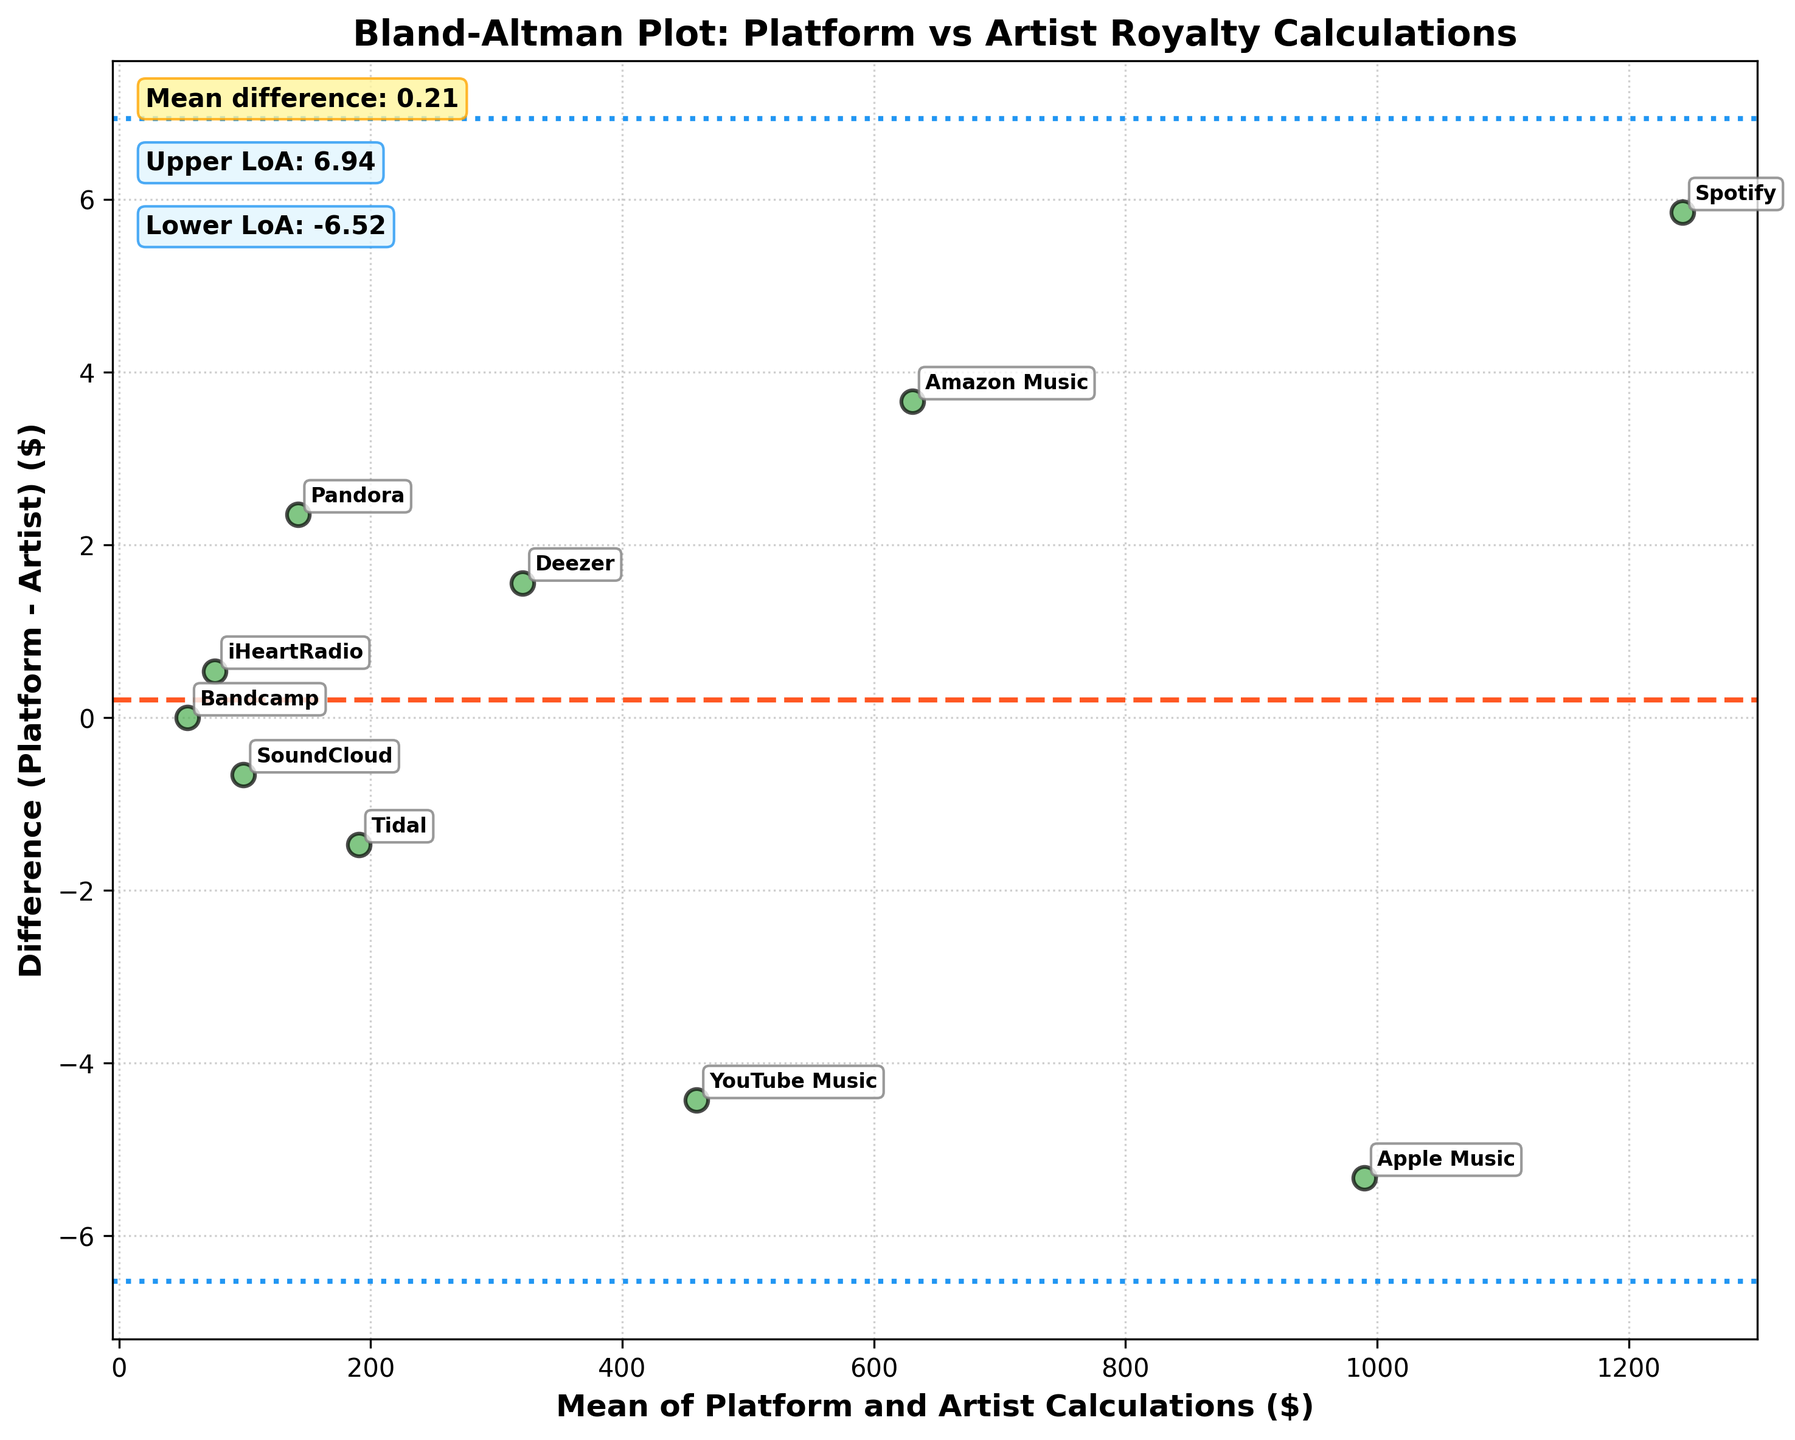How many data points are plotted on the Bland-Altman plot? There are labels for each streaming platform (e.g., Spotify, Apple Music), so counting these labels will give the total number of data points. By counting, there are labels for Spotify, Apple Music, Amazon Music, YouTube Music, Deezer, Tidal, Pandora, SoundCloud, iHeartRadio, and Bandcamp.
Answer: 10 What is the mean difference between the platform and artist royalty calculations? The mean difference is denoted by the dashed orange line. It is also provided in the textbox on the upper left corner of the plot. The value given there is the mean difference.
Answer: -1.12 What are the upper and lower limits of agreement? The upper and lower limits of agreement are shown by the blue dashed lines. Their exact values are given in text boxes in the upper left corner of the plot. According to the figure, the upper limit is 4.28 and the lower limit is -6.52.
Answer: 4.28, -6.52 Which streaming platform has the largest positive difference between platform and artist calculations? By examining the vertical distances above the 0 line, the largest positive difference is for YouTube Music since its marker is the highest above the 0 mark.
Answer: YouTube Music Which streaming platform has the largest negative difference between platform and artist calculations? By examining the vertical distances below the 0 line, the largest negative difference is for Pandora since its marker is the lowest below the 0 mark.
Answer: Pandora Which platform's calculations match exactly with the artist's calculations? By looking for a point where the difference is zero (the 0 line on the y-axis), the only point that lies exactly on this line corresponds to Bandcamp.
Answer: Bandcamp What percentage of the differences fall within the limits of agreement? First count the number of points within the limit of agreement lines. There are 10 points plotted, and all points fall between -6.52 and 4.28. Therefore, 100% of the differences fall within the limits of agreement.
Answer: 100% Is the mean difference closer to the upper or lower limit of agreement? Compare the mean difference (-1.12) to the upper limit (4.28) and lower limit (-6.52). The mean difference is closer to the upper limit, as -1.12 is closer to 4.28 than to -6.52.
Answer: Upper limit 